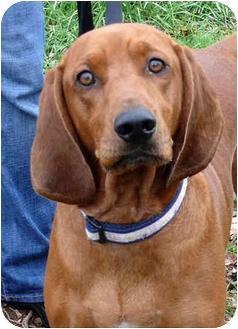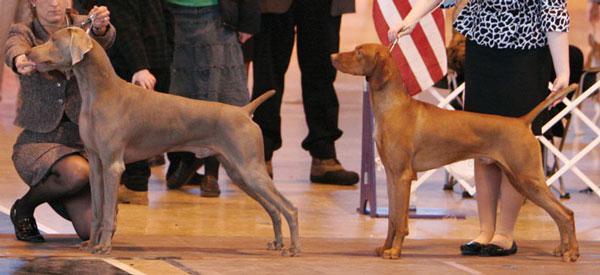The first image is the image on the left, the second image is the image on the right. Examine the images to the left and right. Is the description "There is a total of three dogs." accurate? Answer yes or no. Yes. The first image is the image on the left, the second image is the image on the right. Given the left and right images, does the statement "There are two dogs in the left image." hold true? Answer yes or no. No. 